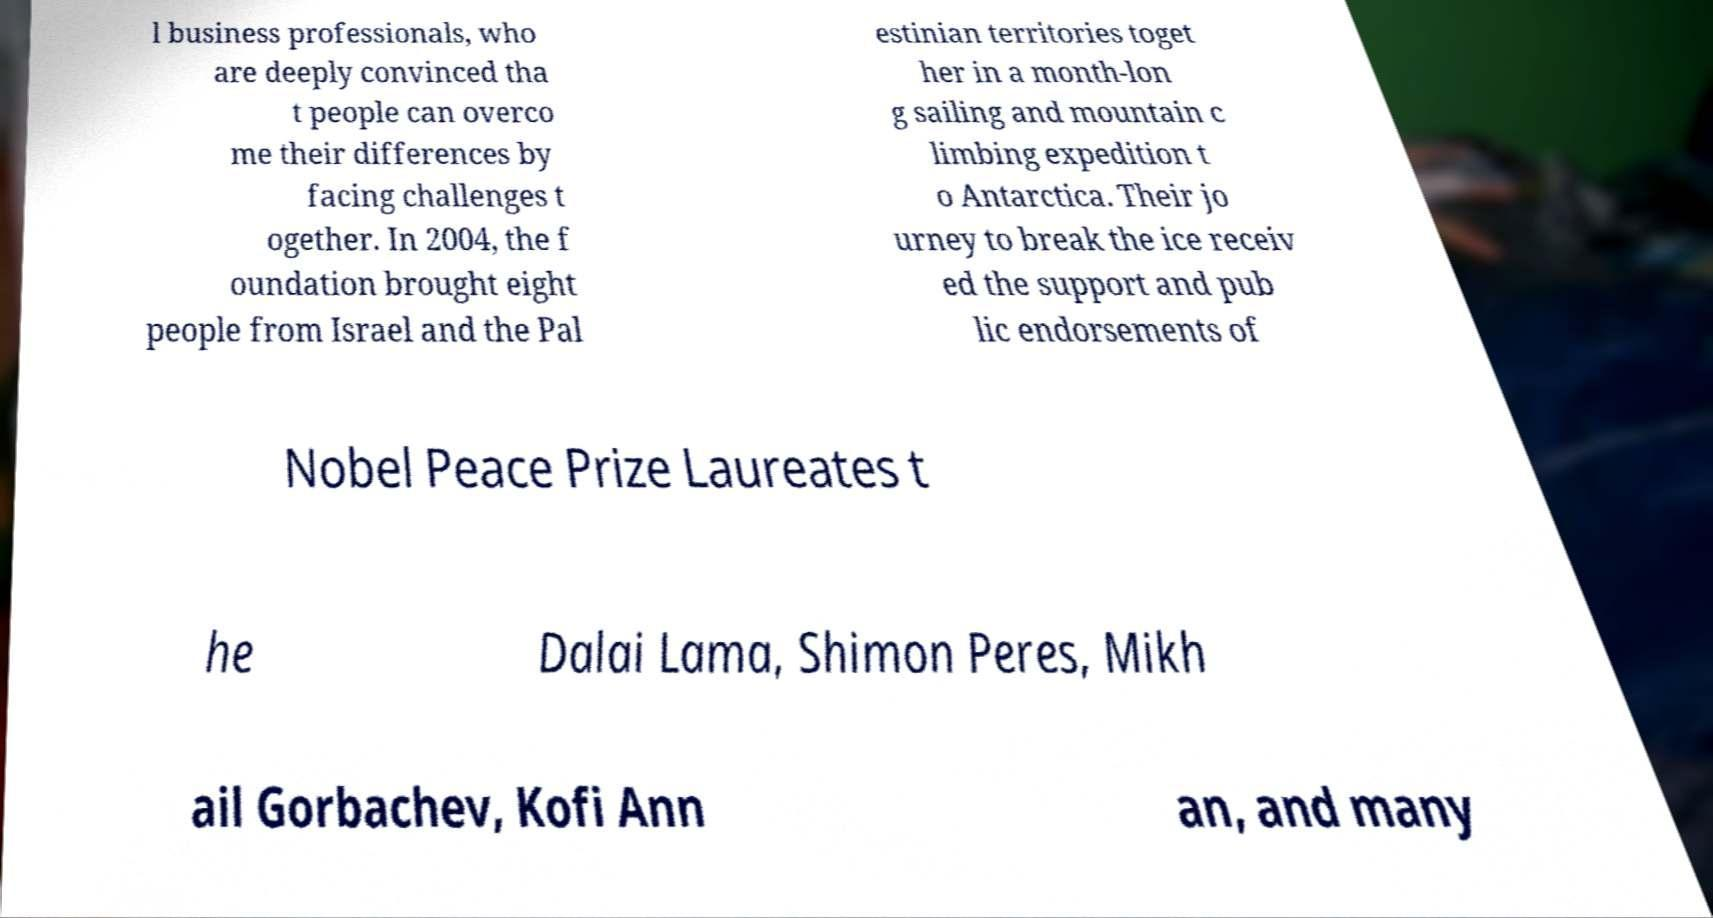What messages or text are displayed in this image? I need them in a readable, typed format. l business professionals, who are deeply convinced tha t people can overco me their differences by facing challenges t ogether. In 2004, the f oundation brought eight people from Israel and the Pal estinian territories toget her in a month-lon g sailing and mountain c limbing expedition t o Antarctica. Their jo urney to break the ice receiv ed the support and pub lic endorsements of Nobel Peace Prize Laureates t he Dalai Lama, Shimon Peres, Mikh ail Gorbachev, Kofi Ann an, and many 